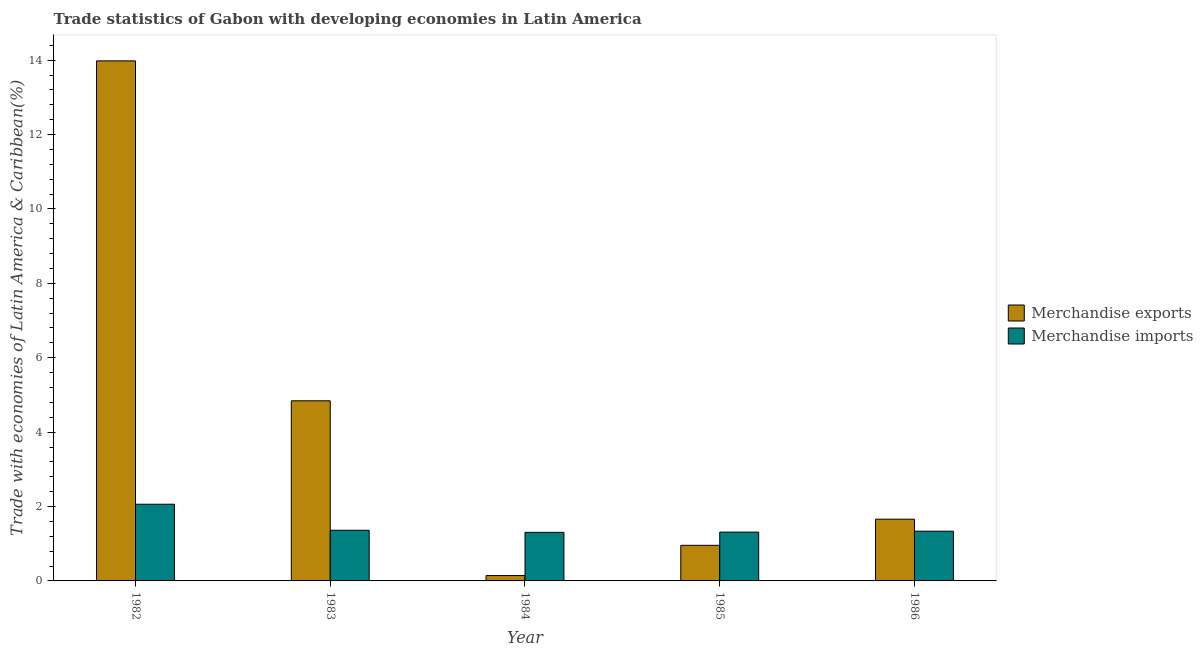How many groups of bars are there?
Offer a terse response. 5. Are the number of bars on each tick of the X-axis equal?
Your response must be concise. Yes. How many bars are there on the 4th tick from the right?
Offer a terse response. 2. What is the label of the 3rd group of bars from the left?
Your answer should be very brief. 1984. In how many cases, is the number of bars for a given year not equal to the number of legend labels?
Ensure brevity in your answer.  0. What is the merchandise exports in 1984?
Offer a very short reply. 0.14. Across all years, what is the maximum merchandise exports?
Give a very brief answer. 13.98. Across all years, what is the minimum merchandise imports?
Provide a succinct answer. 1.31. In which year was the merchandise exports maximum?
Keep it short and to the point. 1982. What is the total merchandise imports in the graph?
Provide a succinct answer. 7.38. What is the difference between the merchandise exports in 1984 and that in 1986?
Make the answer very short. -1.52. What is the difference between the merchandise imports in 1986 and the merchandise exports in 1984?
Ensure brevity in your answer.  0.03. What is the average merchandise imports per year?
Ensure brevity in your answer.  1.48. In the year 1985, what is the difference between the merchandise imports and merchandise exports?
Your answer should be very brief. 0. In how many years, is the merchandise exports greater than 8.4 %?
Ensure brevity in your answer.  1. What is the ratio of the merchandise imports in 1982 to that in 1986?
Your answer should be very brief. 1.54. Is the merchandise imports in 1983 less than that in 1986?
Your response must be concise. No. Is the difference between the merchandise exports in 1982 and 1983 greater than the difference between the merchandise imports in 1982 and 1983?
Offer a very short reply. No. What is the difference between the highest and the second highest merchandise exports?
Provide a short and direct response. 9.14. What is the difference between the highest and the lowest merchandise exports?
Your answer should be compact. 13.84. Is the sum of the merchandise imports in 1982 and 1985 greater than the maximum merchandise exports across all years?
Give a very brief answer. Yes. What does the 1st bar from the left in 1985 represents?
Your response must be concise. Merchandise exports. Are all the bars in the graph horizontal?
Your response must be concise. No. What is the difference between two consecutive major ticks on the Y-axis?
Your answer should be compact. 2. Are the values on the major ticks of Y-axis written in scientific E-notation?
Ensure brevity in your answer.  No. Does the graph contain grids?
Offer a terse response. No. What is the title of the graph?
Keep it short and to the point. Trade statistics of Gabon with developing economies in Latin America. Does "Exports of goods" appear as one of the legend labels in the graph?
Give a very brief answer. No. What is the label or title of the X-axis?
Give a very brief answer. Year. What is the label or title of the Y-axis?
Your answer should be very brief. Trade with economies of Latin America & Caribbean(%). What is the Trade with economies of Latin America & Caribbean(%) of Merchandise exports in 1982?
Your response must be concise. 13.98. What is the Trade with economies of Latin America & Caribbean(%) in Merchandise imports in 1982?
Offer a terse response. 2.06. What is the Trade with economies of Latin America & Caribbean(%) of Merchandise exports in 1983?
Ensure brevity in your answer.  4.84. What is the Trade with economies of Latin America & Caribbean(%) in Merchandise imports in 1983?
Your answer should be compact. 1.36. What is the Trade with economies of Latin America & Caribbean(%) in Merchandise exports in 1984?
Your answer should be very brief. 0.14. What is the Trade with economies of Latin America & Caribbean(%) in Merchandise imports in 1984?
Your answer should be compact. 1.31. What is the Trade with economies of Latin America & Caribbean(%) of Merchandise exports in 1985?
Your response must be concise. 0.96. What is the Trade with economies of Latin America & Caribbean(%) in Merchandise imports in 1985?
Ensure brevity in your answer.  1.31. What is the Trade with economies of Latin America & Caribbean(%) of Merchandise exports in 1986?
Your answer should be compact. 1.66. What is the Trade with economies of Latin America & Caribbean(%) of Merchandise imports in 1986?
Keep it short and to the point. 1.34. Across all years, what is the maximum Trade with economies of Latin America & Caribbean(%) of Merchandise exports?
Offer a very short reply. 13.98. Across all years, what is the maximum Trade with economies of Latin America & Caribbean(%) of Merchandise imports?
Offer a very short reply. 2.06. Across all years, what is the minimum Trade with economies of Latin America & Caribbean(%) of Merchandise exports?
Provide a succinct answer. 0.14. Across all years, what is the minimum Trade with economies of Latin America & Caribbean(%) in Merchandise imports?
Keep it short and to the point. 1.31. What is the total Trade with economies of Latin America & Caribbean(%) in Merchandise exports in the graph?
Your response must be concise. 21.58. What is the total Trade with economies of Latin America & Caribbean(%) of Merchandise imports in the graph?
Offer a very short reply. 7.38. What is the difference between the Trade with economies of Latin America & Caribbean(%) of Merchandise exports in 1982 and that in 1983?
Provide a succinct answer. 9.14. What is the difference between the Trade with economies of Latin America & Caribbean(%) in Merchandise imports in 1982 and that in 1983?
Make the answer very short. 0.7. What is the difference between the Trade with economies of Latin America & Caribbean(%) in Merchandise exports in 1982 and that in 1984?
Your response must be concise. 13.84. What is the difference between the Trade with economies of Latin America & Caribbean(%) of Merchandise imports in 1982 and that in 1984?
Provide a succinct answer. 0.76. What is the difference between the Trade with economies of Latin America & Caribbean(%) of Merchandise exports in 1982 and that in 1985?
Give a very brief answer. 13.02. What is the difference between the Trade with economies of Latin America & Caribbean(%) in Merchandise imports in 1982 and that in 1985?
Provide a succinct answer. 0.75. What is the difference between the Trade with economies of Latin America & Caribbean(%) of Merchandise exports in 1982 and that in 1986?
Keep it short and to the point. 12.32. What is the difference between the Trade with economies of Latin America & Caribbean(%) in Merchandise imports in 1982 and that in 1986?
Your answer should be compact. 0.72. What is the difference between the Trade with economies of Latin America & Caribbean(%) in Merchandise exports in 1983 and that in 1984?
Give a very brief answer. 4.7. What is the difference between the Trade with economies of Latin America & Caribbean(%) in Merchandise imports in 1983 and that in 1984?
Your answer should be compact. 0.06. What is the difference between the Trade with economies of Latin America & Caribbean(%) of Merchandise exports in 1983 and that in 1985?
Ensure brevity in your answer.  3.89. What is the difference between the Trade with economies of Latin America & Caribbean(%) in Merchandise imports in 1983 and that in 1985?
Give a very brief answer. 0.05. What is the difference between the Trade with economies of Latin America & Caribbean(%) of Merchandise exports in 1983 and that in 1986?
Provide a short and direct response. 3.18. What is the difference between the Trade with economies of Latin America & Caribbean(%) of Merchandise imports in 1983 and that in 1986?
Make the answer very short. 0.02. What is the difference between the Trade with economies of Latin America & Caribbean(%) in Merchandise exports in 1984 and that in 1985?
Make the answer very short. -0.81. What is the difference between the Trade with economies of Latin America & Caribbean(%) in Merchandise imports in 1984 and that in 1985?
Ensure brevity in your answer.  -0.01. What is the difference between the Trade with economies of Latin America & Caribbean(%) in Merchandise exports in 1984 and that in 1986?
Offer a terse response. -1.52. What is the difference between the Trade with economies of Latin America & Caribbean(%) in Merchandise imports in 1984 and that in 1986?
Offer a very short reply. -0.03. What is the difference between the Trade with economies of Latin America & Caribbean(%) of Merchandise exports in 1985 and that in 1986?
Offer a terse response. -0.7. What is the difference between the Trade with economies of Latin America & Caribbean(%) of Merchandise imports in 1985 and that in 1986?
Provide a succinct answer. -0.02. What is the difference between the Trade with economies of Latin America & Caribbean(%) in Merchandise exports in 1982 and the Trade with economies of Latin America & Caribbean(%) in Merchandise imports in 1983?
Give a very brief answer. 12.62. What is the difference between the Trade with economies of Latin America & Caribbean(%) in Merchandise exports in 1982 and the Trade with economies of Latin America & Caribbean(%) in Merchandise imports in 1984?
Your answer should be compact. 12.67. What is the difference between the Trade with economies of Latin America & Caribbean(%) in Merchandise exports in 1982 and the Trade with economies of Latin America & Caribbean(%) in Merchandise imports in 1985?
Ensure brevity in your answer.  12.67. What is the difference between the Trade with economies of Latin America & Caribbean(%) of Merchandise exports in 1982 and the Trade with economies of Latin America & Caribbean(%) of Merchandise imports in 1986?
Your answer should be compact. 12.64. What is the difference between the Trade with economies of Latin America & Caribbean(%) in Merchandise exports in 1983 and the Trade with economies of Latin America & Caribbean(%) in Merchandise imports in 1984?
Ensure brevity in your answer.  3.54. What is the difference between the Trade with economies of Latin America & Caribbean(%) of Merchandise exports in 1983 and the Trade with economies of Latin America & Caribbean(%) of Merchandise imports in 1985?
Offer a terse response. 3.53. What is the difference between the Trade with economies of Latin America & Caribbean(%) of Merchandise exports in 1983 and the Trade with economies of Latin America & Caribbean(%) of Merchandise imports in 1986?
Keep it short and to the point. 3.51. What is the difference between the Trade with economies of Latin America & Caribbean(%) of Merchandise exports in 1984 and the Trade with economies of Latin America & Caribbean(%) of Merchandise imports in 1985?
Offer a terse response. -1.17. What is the difference between the Trade with economies of Latin America & Caribbean(%) in Merchandise exports in 1984 and the Trade with economies of Latin America & Caribbean(%) in Merchandise imports in 1986?
Give a very brief answer. -1.19. What is the difference between the Trade with economies of Latin America & Caribbean(%) of Merchandise exports in 1985 and the Trade with economies of Latin America & Caribbean(%) of Merchandise imports in 1986?
Keep it short and to the point. -0.38. What is the average Trade with economies of Latin America & Caribbean(%) in Merchandise exports per year?
Provide a succinct answer. 4.32. What is the average Trade with economies of Latin America & Caribbean(%) in Merchandise imports per year?
Your response must be concise. 1.48. In the year 1982, what is the difference between the Trade with economies of Latin America & Caribbean(%) of Merchandise exports and Trade with economies of Latin America & Caribbean(%) of Merchandise imports?
Offer a very short reply. 11.92. In the year 1983, what is the difference between the Trade with economies of Latin America & Caribbean(%) of Merchandise exports and Trade with economies of Latin America & Caribbean(%) of Merchandise imports?
Make the answer very short. 3.48. In the year 1984, what is the difference between the Trade with economies of Latin America & Caribbean(%) in Merchandise exports and Trade with economies of Latin America & Caribbean(%) in Merchandise imports?
Ensure brevity in your answer.  -1.16. In the year 1985, what is the difference between the Trade with economies of Latin America & Caribbean(%) of Merchandise exports and Trade with economies of Latin America & Caribbean(%) of Merchandise imports?
Keep it short and to the point. -0.36. In the year 1986, what is the difference between the Trade with economies of Latin America & Caribbean(%) of Merchandise exports and Trade with economies of Latin America & Caribbean(%) of Merchandise imports?
Provide a short and direct response. 0.32. What is the ratio of the Trade with economies of Latin America & Caribbean(%) in Merchandise exports in 1982 to that in 1983?
Your answer should be very brief. 2.89. What is the ratio of the Trade with economies of Latin America & Caribbean(%) of Merchandise imports in 1982 to that in 1983?
Offer a very short reply. 1.51. What is the ratio of the Trade with economies of Latin America & Caribbean(%) of Merchandise exports in 1982 to that in 1984?
Your answer should be compact. 96.84. What is the ratio of the Trade with economies of Latin America & Caribbean(%) of Merchandise imports in 1982 to that in 1984?
Keep it short and to the point. 1.58. What is the ratio of the Trade with economies of Latin America & Caribbean(%) in Merchandise exports in 1982 to that in 1985?
Provide a short and direct response. 14.61. What is the ratio of the Trade with economies of Latin America & Caribbean(%) of Merchandise imports in 1982 to that in 1985?
Keep it short and to the point. 1.57. What is the ratio of the Trade with economies of Latin America & Caribbean(%) in Merchandise exports in 1982 to that in 1986?
Make the answer very short. 8.42. What is the ratio of the Trade with economies of Latin America & Caribbean(%) of Merchandise imports in 1982 to that in 1986?
Provide a succinct answer. 1.54. What is the ratio of the Trade with economies of Latin America & Caribbean(%) of Merchandise exports in 1983 to that in 1984?
Keep it short and to the point. 33.54. What is the ratio of the Trade with economies of Latin America & Caribbean(%) in Merchandise imports in 1983 to that in 1984?
Provide a succinct answer. 1.04. What is the ratio of the Trade with economies of Latin America & Caribbean(%) in Merchandise exports in 1983 to that in 1985?
Give a very brief answer. 5.06. What is the ratio of the Trade with economies of Latin America & Caribbean(%) of Merchandise imports in 1983 to that in 1985?
Make the answer very short. 1.04. What is the ratio of the Trade with economies of Latin America & Caribbean(%) of Merchandise exports in 1983 to that in 1986?
Offer a terse response. 2.92. What is the ratio of the Trade with economies of Latin America & Caribbean(%) of Merchandise imports in 1983 to that in 1986?
Make the answer very short. 1.02. What is the ratio of the Trade with economies of Latin America & Caribbean(%) of Merchandise exports in 1984 to that in 1985?
Offer a very short reply. 0.15. What is the ratio of the Trade with economies of Latin America & Caribbean(%) of Merchandise exports in 1984 to that in 1986?
Your answer should be very brief. 0.09. What is the ratio of the Trade with economies of Latin America & Caribbean(%) of Merchandise imports in 1984 to that in 1986?
Give a very brief answer. 0.98. What is the ratio of the Trade with economies of Latin America & Caribbean(%) in Merchandise exports in 1985 to that in 1986?
Keep it short and to the point. 0.58. What is the ratio of the Trade with economies of Latin America & Caribbean(%) of Merchandise imports in 1985 to that in 1986?
Your answer should be very brief. 0.98. What is the difference between the highest and the second highest Trade with economies of Latin America & Caribbean(%) in Merchandise exports?
Provide a short and direct response. 9.14. What is the difference between the highest and the second highest Trade with economies of Latin America & Caribbean(%) of Merchandise imports?
Provide a succinct answer. 0.7. What is the difference between the highest and the lowest Trade with economies of Latin America & Caribbean(%) in Merchandise exports?
Make the answer very short. 13.84. What is the difference between the highest and the lowest Trade with economies of Latin America & Caribbean(%) of Merchandise imports?
Keep it short and to the point. 0.76. 